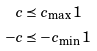<formula> <loc_0><loc_0><loc_500><loc_500>c & \preceq c _ { \max } 1 \\ - c & \preceq - c _ { \min } 1</formula> 